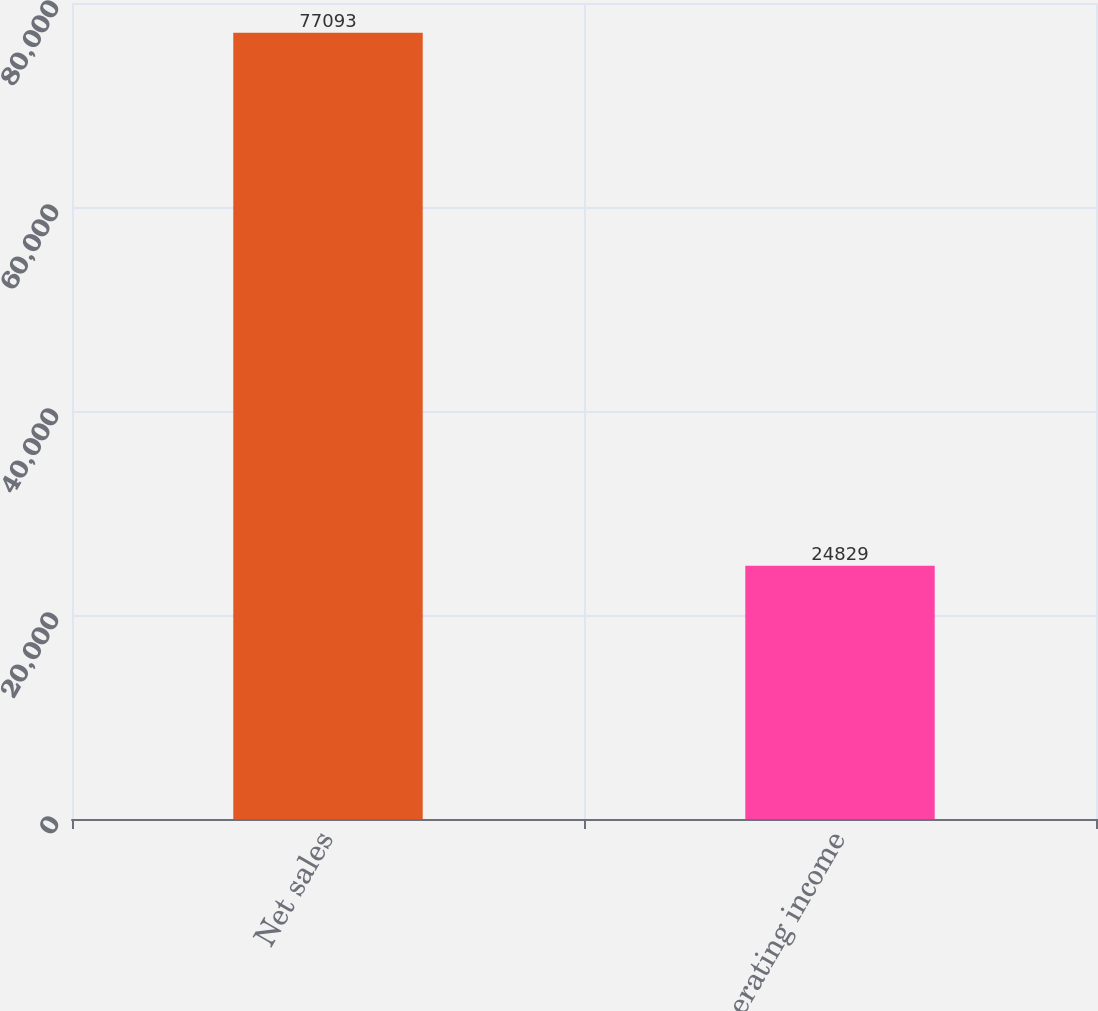<chart> <loc_0><loc_0><loc_500><loc_500><bar_chart><fcel>Net sales<fcel>Operating income<nl><fcel>77093<fcel>24829<nl></chart> 